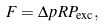Convert formula to latex. <formula><loc_0><loc_0><loc_500><loc_500>F = \Delta p R P _ { \text {exc} } ,</formula> 